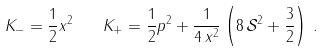Convert formula to latex. <formula><loc_0><loc_0><loc_500><loc_500>K _ { - } = \frac { 1 } { 2 } x ^ { 2 } \quad K _ { + } = \frac { 1 } { 2 } p ^ { 2 } + \frac { 1 } { 4 \, x ^ { 2 } } \left ( 8 \, \mathcal { S } ^ { 2 } + \frac { 3 } { 2 } \right ) \, .</formula> 